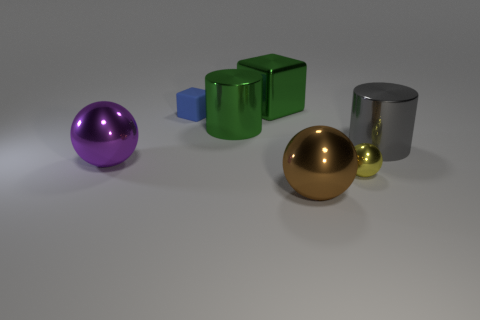Subtract all gray blocks. Subtract all green balls. How many blocks are left? 2 Add 1 gray shiny things. How many objects exist? 8 Subtract all cubes. How many objects are left? 5 Subtract all small blue matte balls. Subtract all big green cylinders. How many objects are left? 6 Add 5 metallic cylinders. How many metallic cylinders are left? 7 Add 7 big gray cylinders. How many big gray cylinders exist? 8 Subtract 0 brown cylinders. How many objects are left? 7 